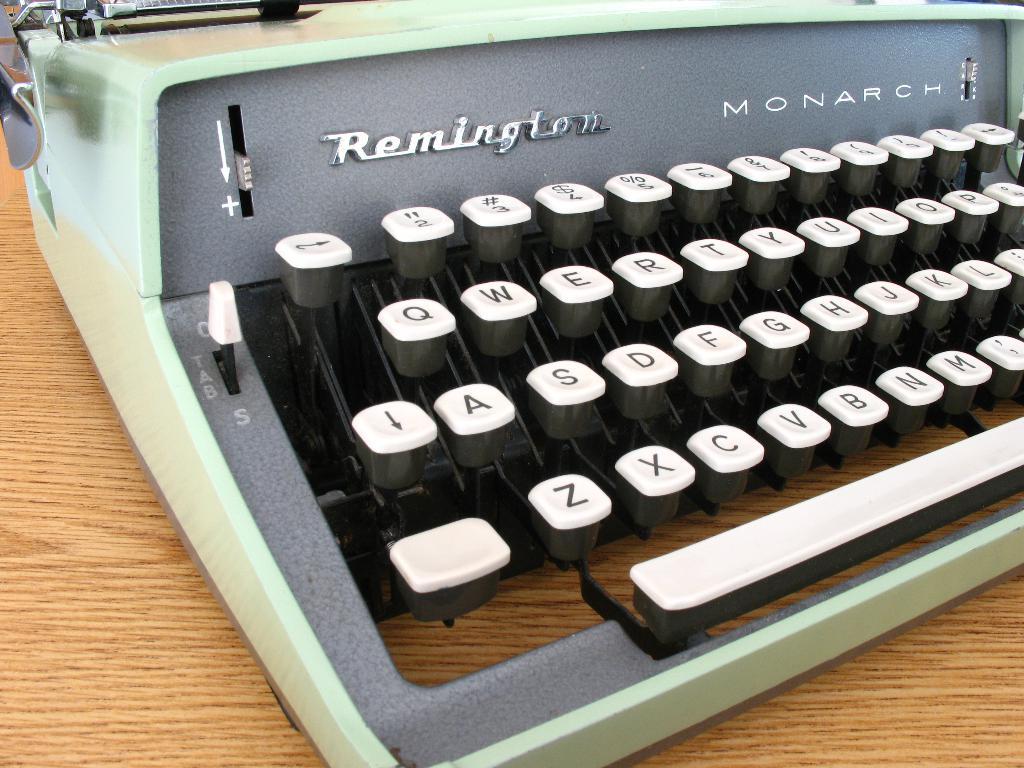What brand of typewriter is this?
Give a very brief answer. Remington. 